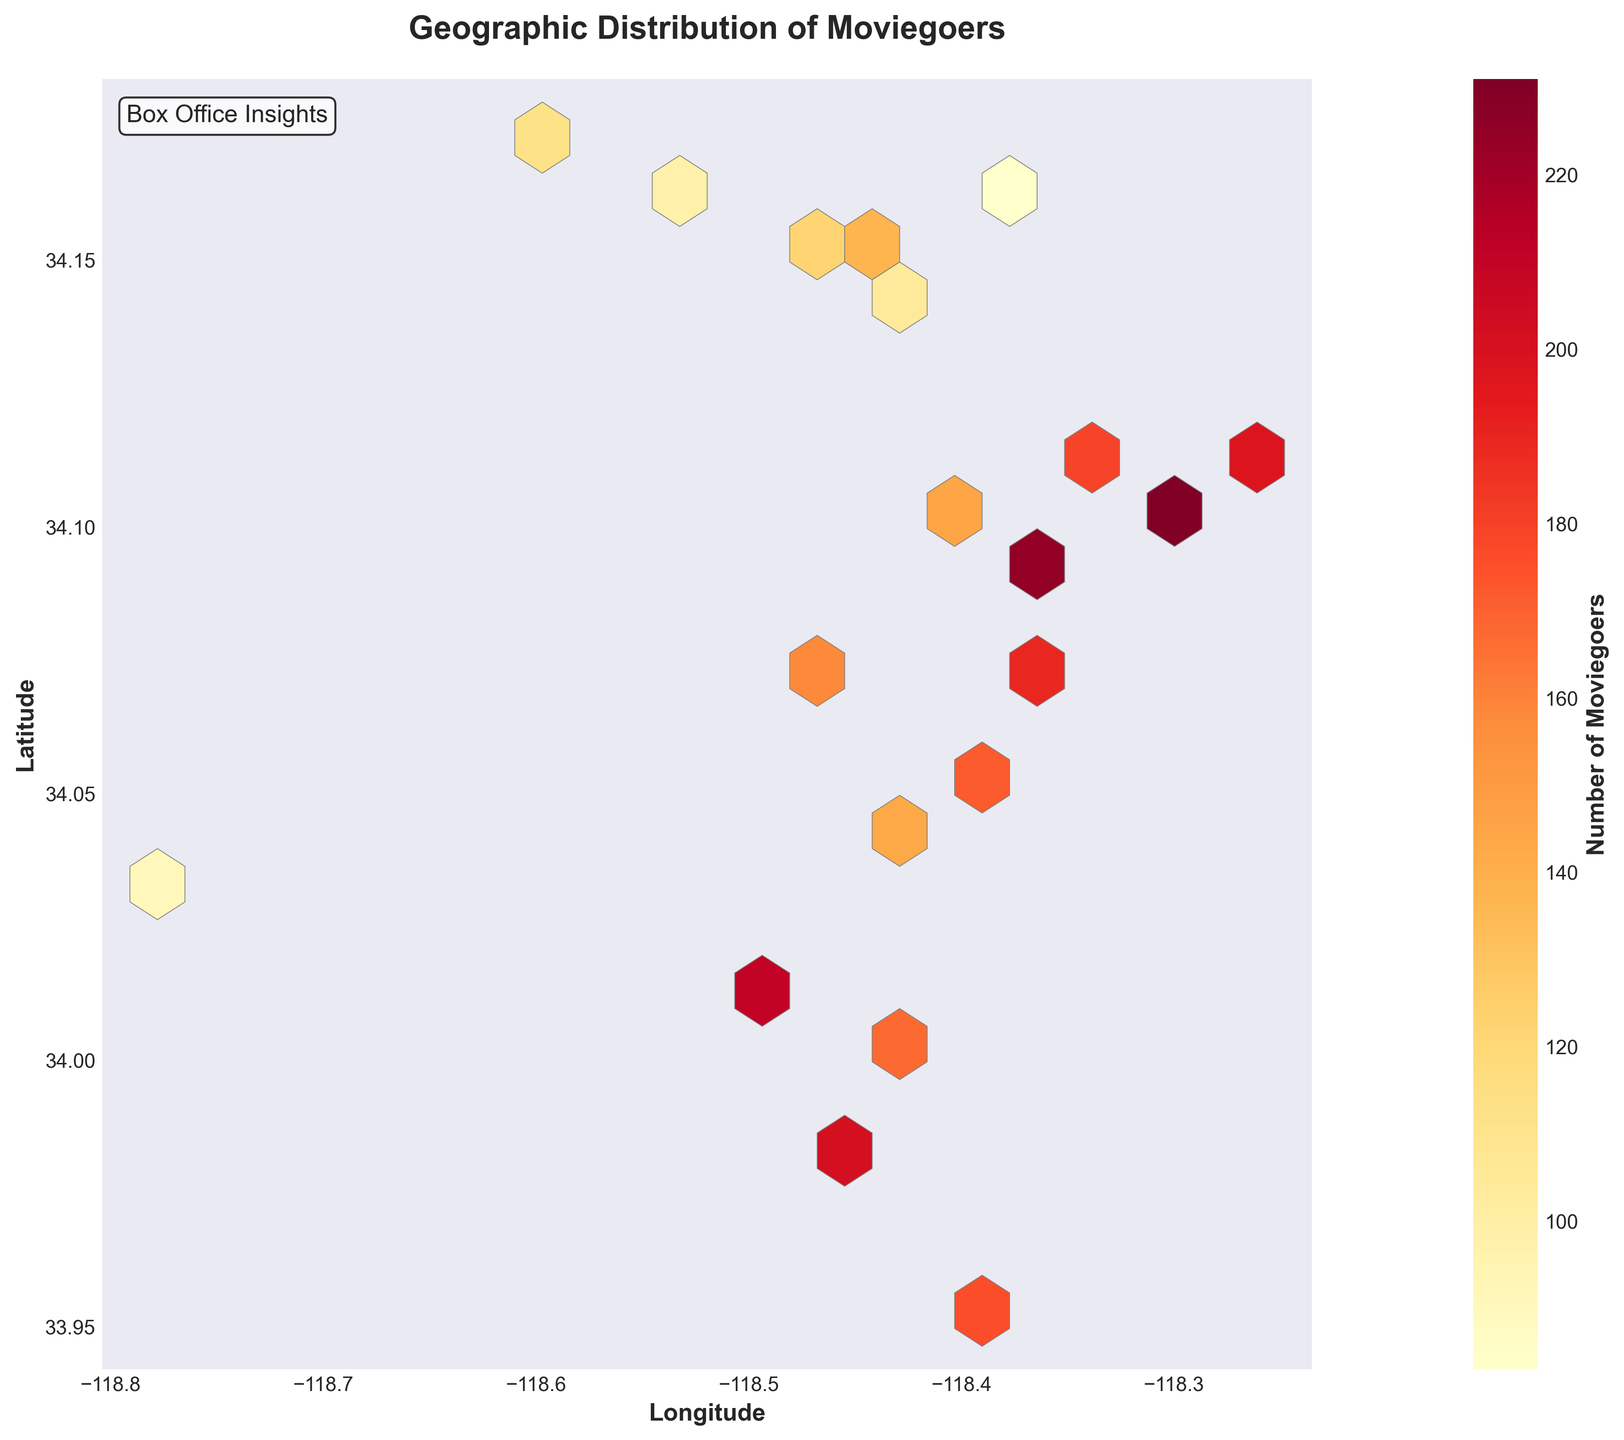How many hexagons are there in the plot? To determine the number of hexagons, visually count all the hexagons displayed on the plot.
Answer: 20 What does the color gradient from yellow to red signify? The color gradient indicates the number of moviegoers in each geographic region, with yellow representing fewer moviegoers and red indicating more moviegoers.
Answer: Number of moviegoers Where is the highest concentration of moviegoers located geographically? Identify the darkest red hexagons on the plot and note the corresponding latitude and longitude values.
Answer: Around latitude 34.1, longitude -118.3 Which zip code has the highest count of moviegoers, as observed from the plot? Look for the darkest red hexagon and compare it against the zip code data to find the match with the closest latitude and longitude.
Answer: 90027 Is there any area with nearly the same number of moviegoers as the zip code 90291? Compare the color intensity of the hexagon representing 90291 and find another hexagon with similar color intensity.
Answer: Yes, around latitude 34.05, longitude -118.38 Are there more moviegoers concentrated in the latitudes around 34.1 or around 34.15? Compare the density of hexagons with significant colors (yellow to red) around latitudes 34.1 and 34.15 to determine where more moviegoers are concentrated.
Answer: Around 34.1 How does the number of moviegoers vary as you move from west to east in the plot? Observe the color change from the leftmost hexagons (west) to the rightmost hexagons (east). Notice if the colors tend to get lighter or darker.
Answer: Generally decreases Does any area near a latitude of 34 and longitude of -118.4 have a high concentration of moviegoers? Check the color of the hexagons near the specified coordinates to see if they are close to red.
Answer: Yes What is the average number of moviegoers for the zip codes represented in the plot? Sum the number of moviegoers for all zip codes and divide by the total number of zip codes (19). (145+210+98+176+189+122+231+167+83+158+201+112+179+225+104+143+198+137+91+172 = 2741, 2741/19 = 144.26)
Answer: 144.26 